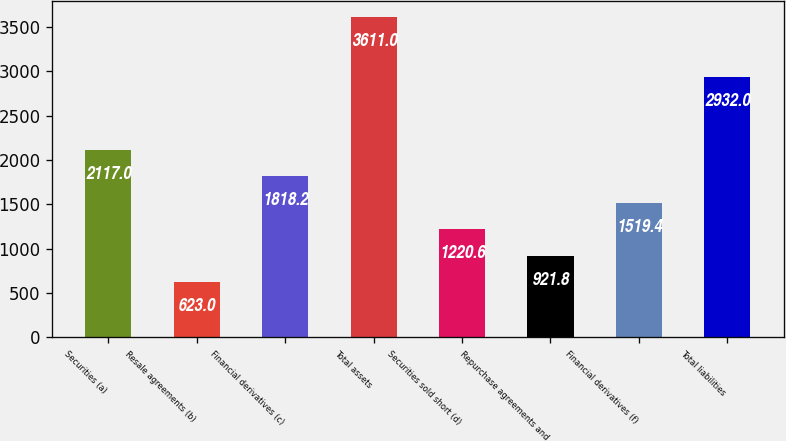Convert chart. <chart><loc_0><loc_0><loc_500><loc_500><bar_chart><fcel>Securities (a)<fcel>Resale agreements (b)<fcel>Financial derivatives (c)<fcel>Total assets<fcel>Securities sold short (d)<fcel>Repurchase agreements and<fcel>Financial derivatives (f)<fcel>Total liabilities<nl><fcel>2117<fcel>623<fcel>1818.2<fcel>3611<fcel>1220.6<fcel>921.8<fcel>1519.4<fcel>2932<nl></chart> 